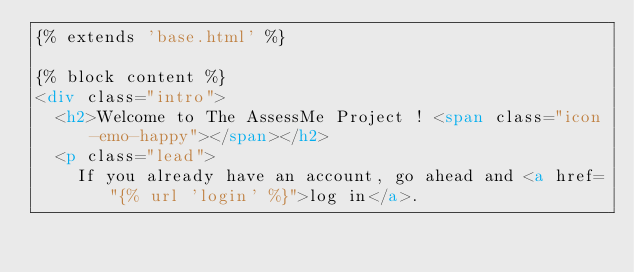<code> <loc_0><loc_0><loc_500><loc_500><_HTML_>{% extends 'base.html' %}

{% block content %}
<div class="intro">
  <h2>Welcome to The AssessMe Project ! <span class="icon-emo-happy"></span></h2>
  <p class="lead">
    If you already have an account, go ahead and <a href="{% url 'login' %}">log in</a>.</code> 